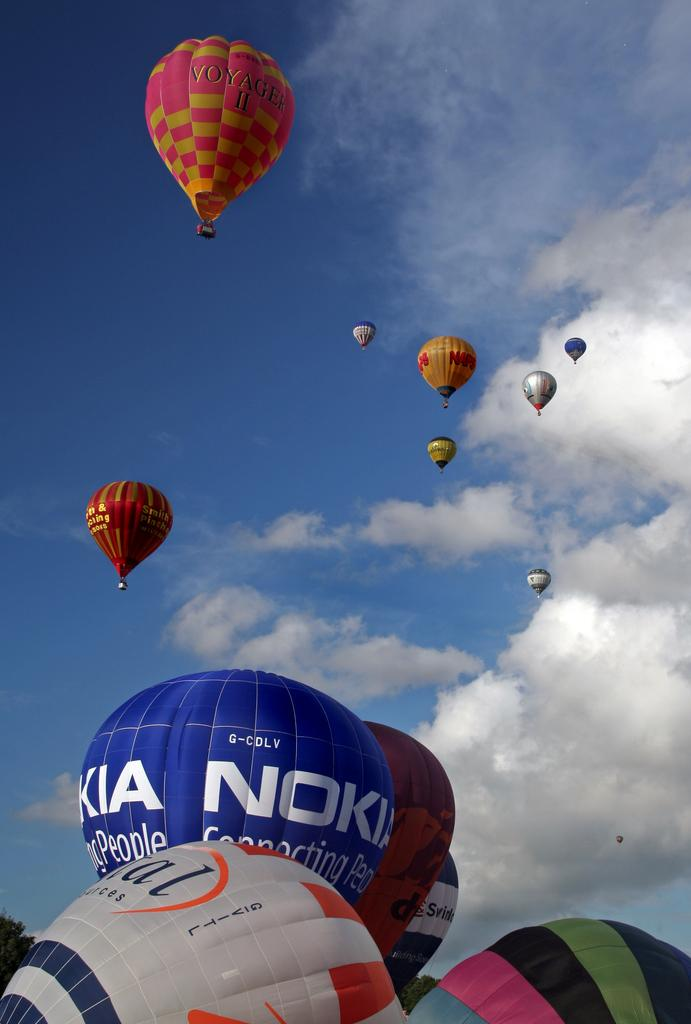<image>
Give a short and clear explanation of the subsequent image. hot air balloons include ones from Voyager II and Nokia 